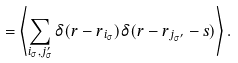<formula> <loc_0><loc_0><loc_500><loc_500>= \left < \sum _ { i _ { \sigma } , j _ { \sigma } ^ { \prime } } \delta ( { r - r } _ { i _ { \sigma } } ) \delta ( { r - r } _ { j _ { \sigma ^ { \prime } } } - { s } ) \right > .</formula> 